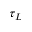Convert formula to latex. <formula><loc_0><loc_0><loc_500><loc_500>\tau _ { L }</formula> 